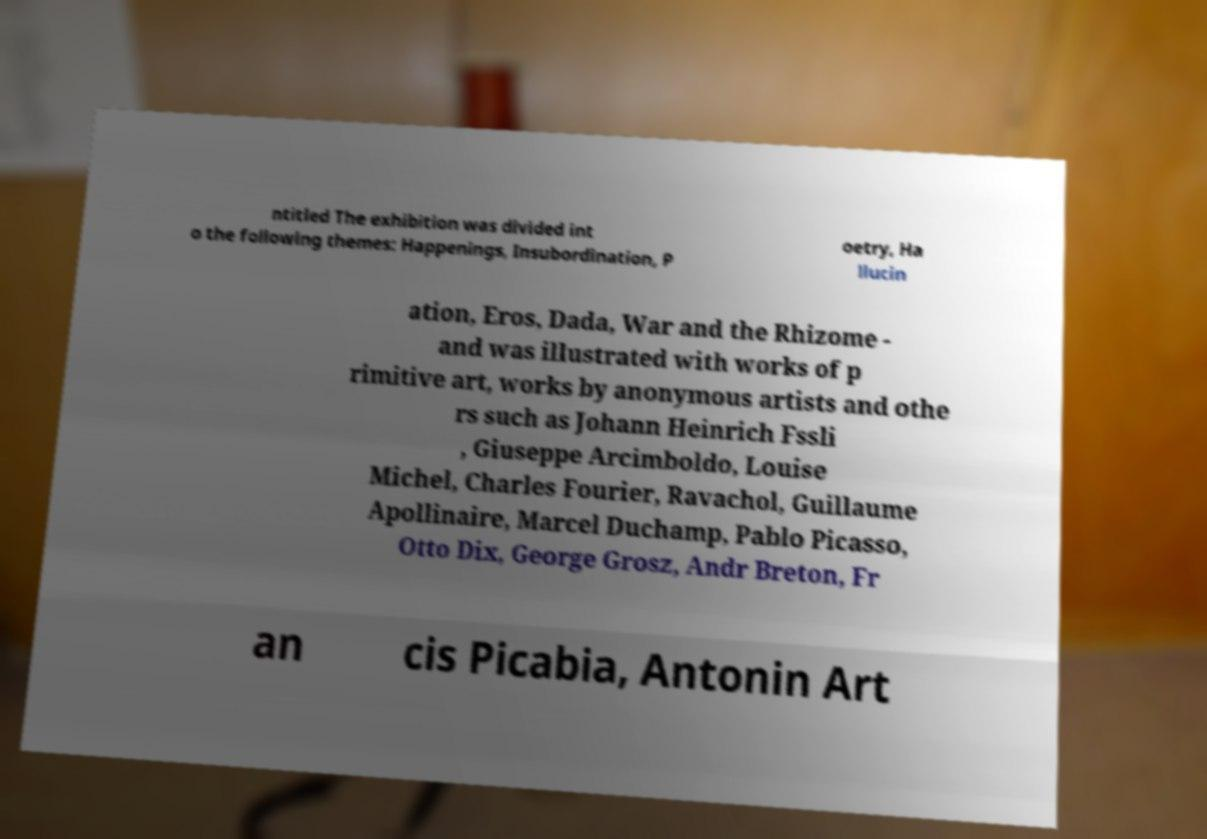Can you accurately transcribe the text from the provided image for me? ntitled The exhibition was divided int o the following themes: Happenings, Insubordination, P oetry, Ha llucin ation, Eros, Dada, War and the Rhizome - and was illustrated with works of p rimitive art, works by anonymous artists and othe rs such as Johann Heinrich Fssli , Giuseppe Arcimboldo, Louise Michel, Charles Fourier, Ravachol, Guillaume Apollinaire, Marcel Duchamp, Pablo Picasso, Otto Dix, George Grosz, Andr Breton, Fr an cis Picabia, Antonin Art 